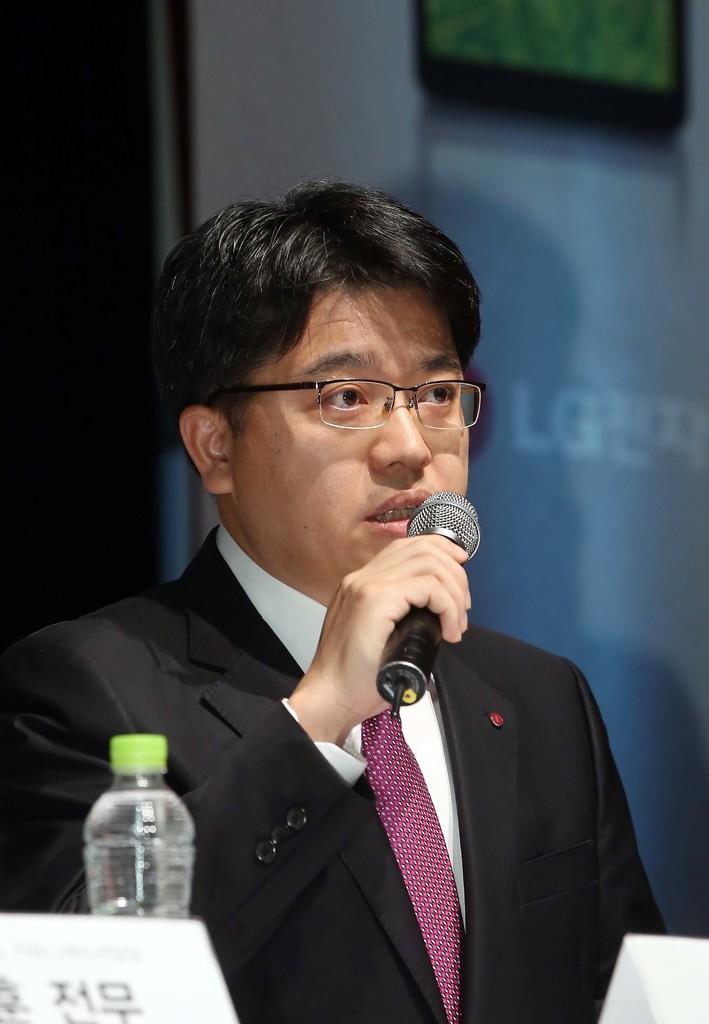In one or two sentences, can you explain what this image depicts? In this image I can see a man in suit and tie. I can also see he is holding a mic and wearing a specs. Here I can see a water bottle. 